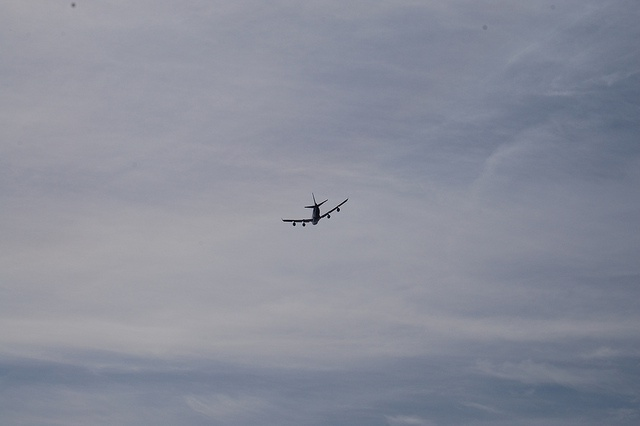Describe the objects in this image and their specific colors. I can see a airplane in darkgray, black, and gray tones in this image. 